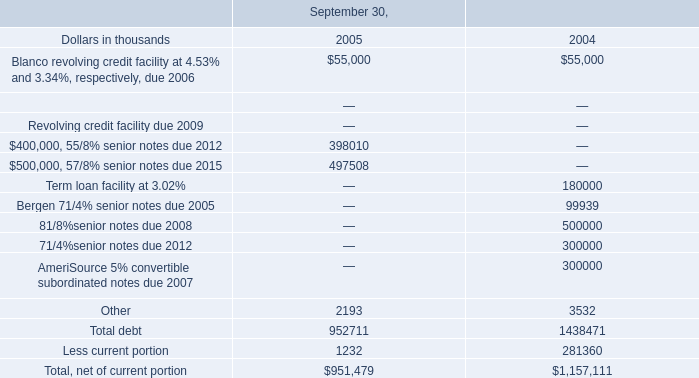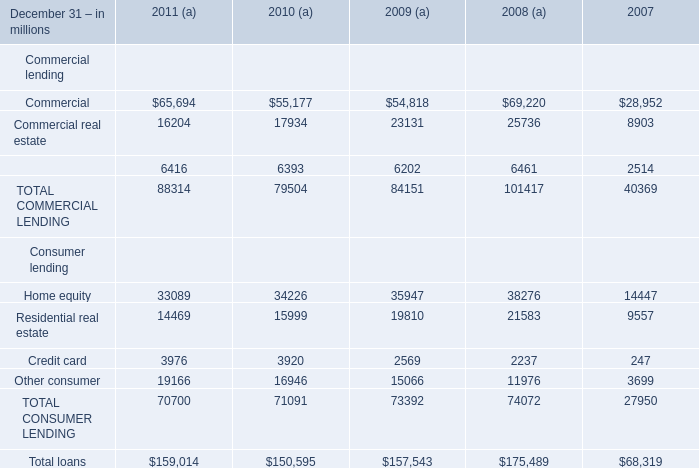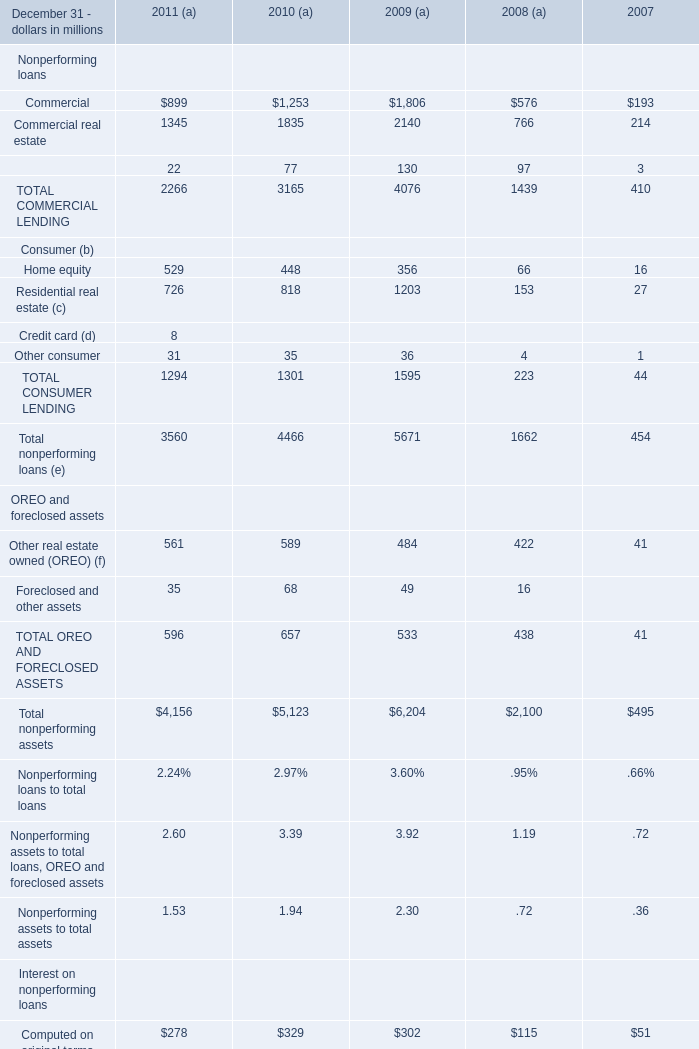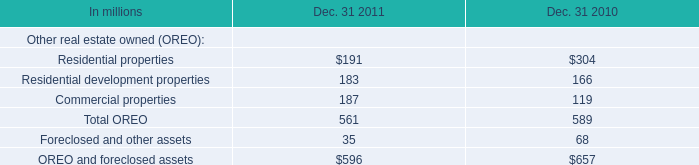What is the difference between the greatest Equipment lease financing in 2011 and 2010? (in million) 
Computations: (77 - 22)
Answer: 55.0. 